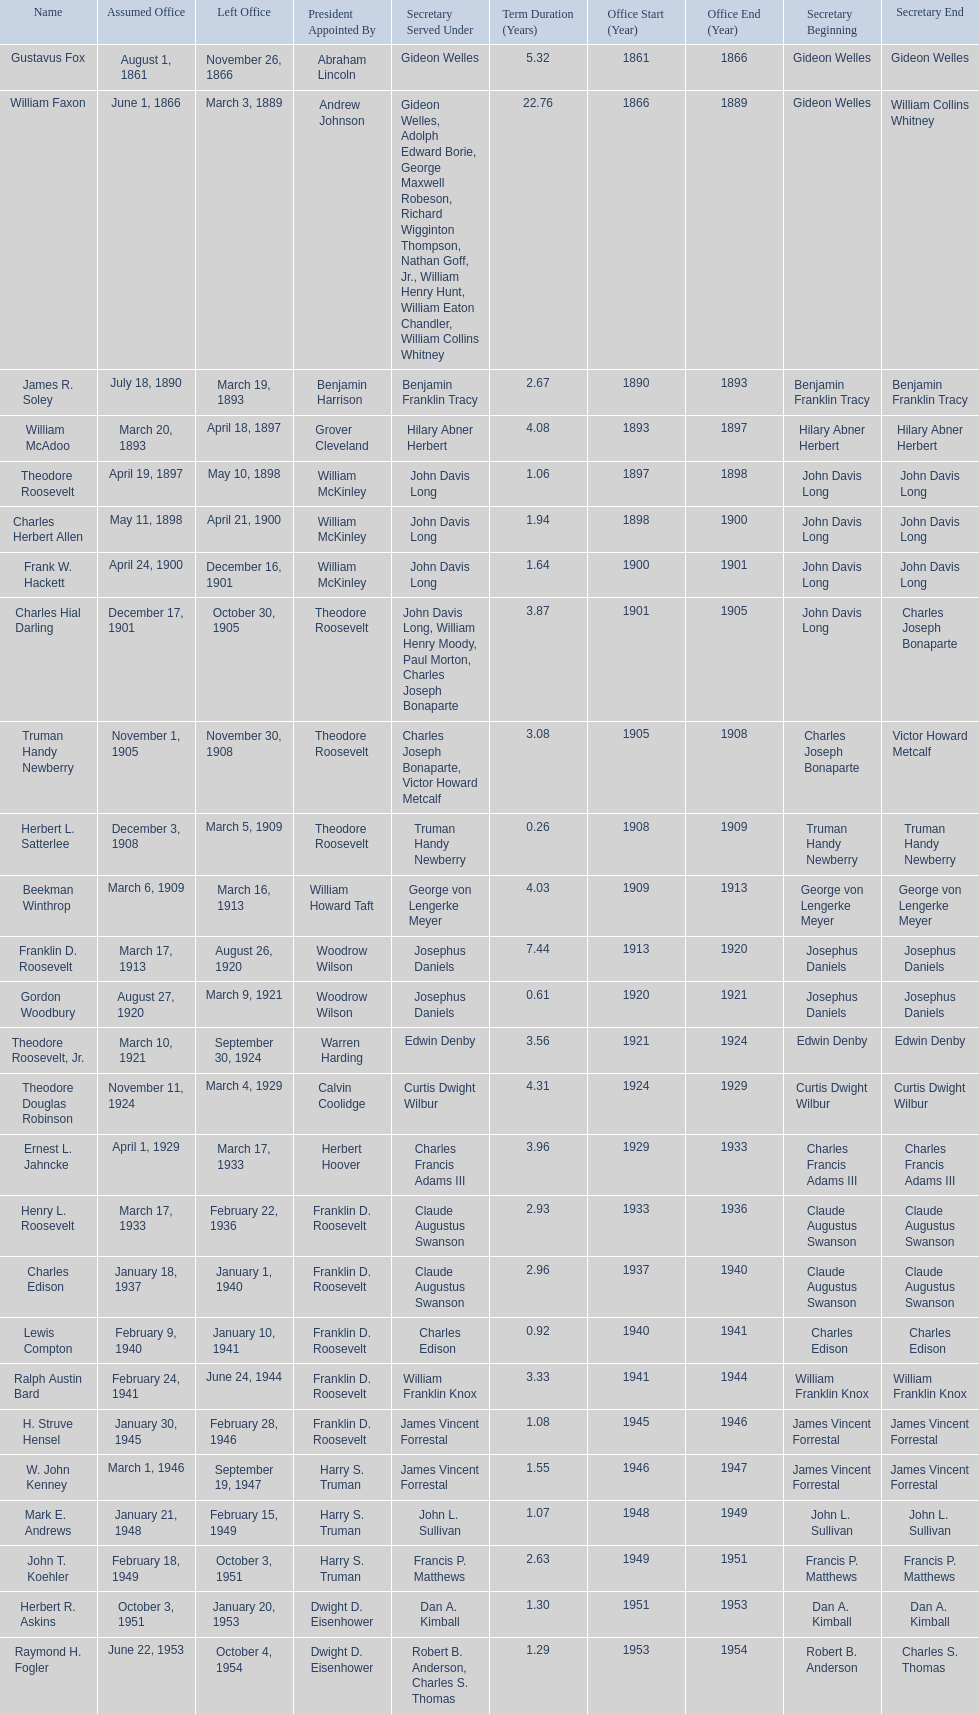When did raymond h. fogler leave the office of assistant secretary of the navy? October 4, 1954. 